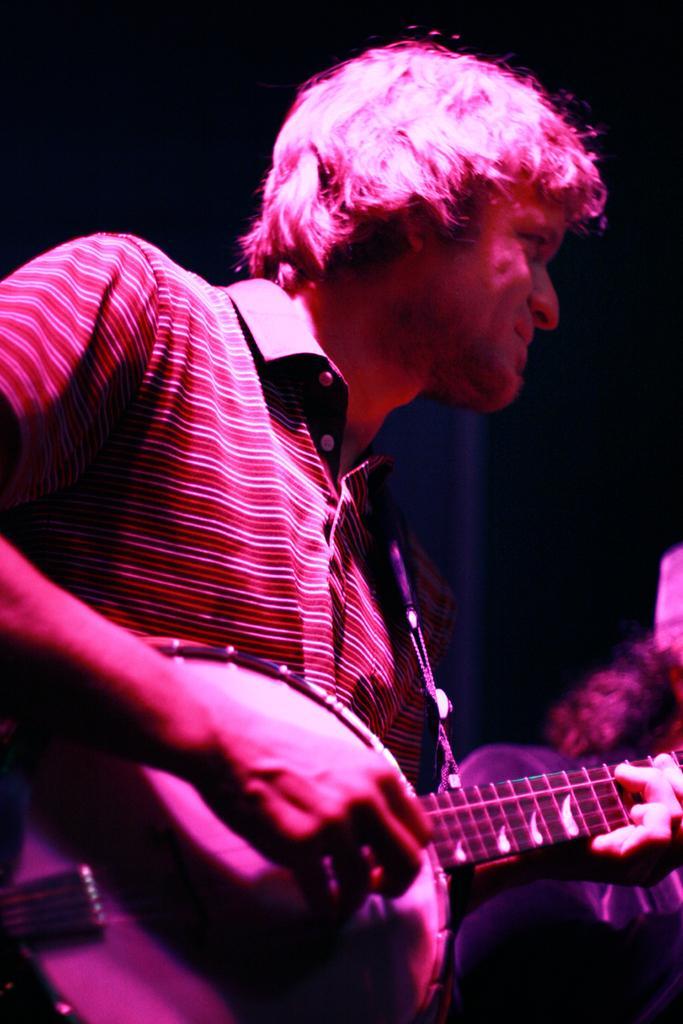Describe this image in one or two sentences. In this picture a guy is playing a guitar , the picture is taken in a concert. To the right side of the image there are people standing. 